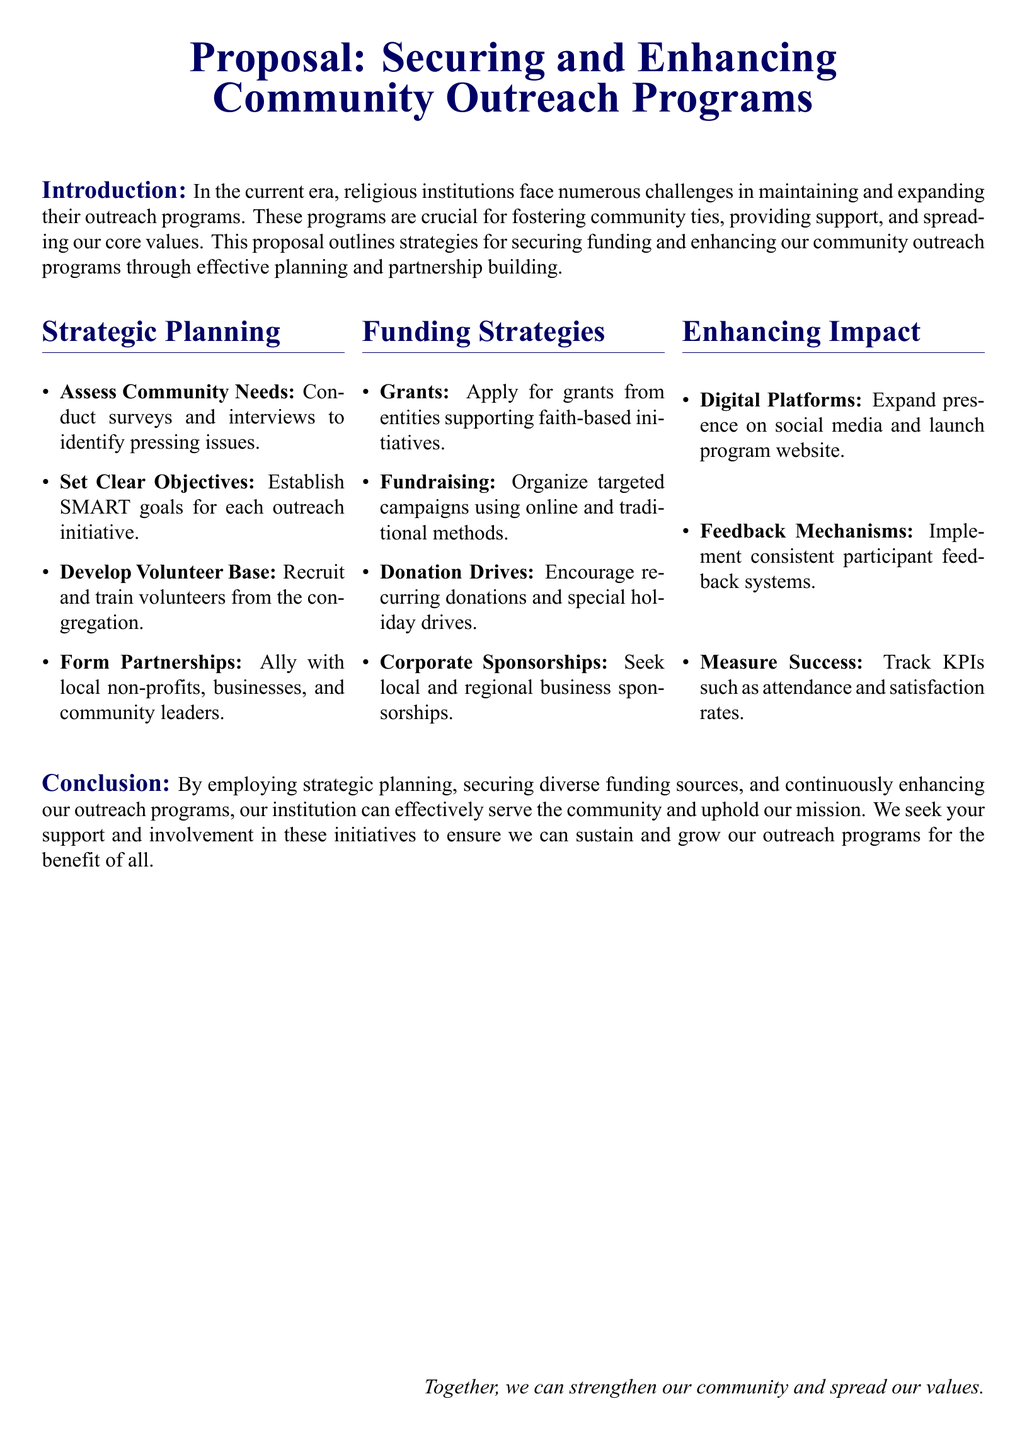What are the two main components of this proposal? The proposal focuses on securing funding and enhancing community outreach programs.
Answer: funding and enhancing community outreach programs What does SMART stand for in the context of setting objectives? SMART goals are specific, measurable, achievable, relevant, and time-bound.
Answer: specific, measurable, achievable, relevant, time-bound How many funding strategies are listed in the document? There are four distinct funding strategies outlined in the proposal.
Answer: four What is one method suggested for assessing community needs? Conducting surveys and interviews is a suggested method for assessing community needs.
Answer: surveys and interviews Which type of sponsorship is mentioned as a funding strategy? Corporate sponsorships are highlighted as a potential source of funding in the proposal.
Answer: Corporate sponsorships What is emphasized as a method for measuring the success of outreach programs? Tracking KPIs such as attendance and satisfaction rates is essential for measuring success.
Answer: Tracking KPIs What type of platforms does the proposal suggest expanding for outreach? The proposal suggests expanding digital platforms, specifically social media and a program website, for outreach efforts.
Answer: digital platforms What is mentioned as an important mechanism for gathering participant feedback? Implementing consistent participant feedback systems is mentioned as an important mechanism.
Answer: feedback systems 